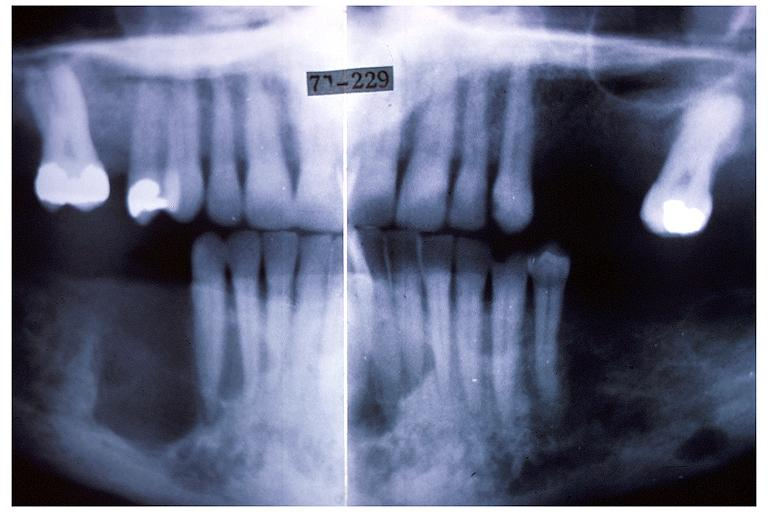does this image show hyperparathyroidism brown tumor?
Answer the question using a single word or phrase. Yes 